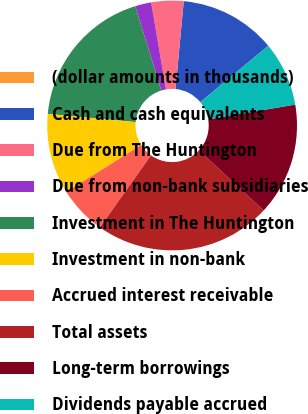Convert chart to OTSL. <chart><loc_0><loc_0><loc_500><loc_500><pie_chart><fcel>(dollar amounts in thousands)<fcel>Cash and cash equivalents<fcel>Due from The Huntington<fcel>Due from non-bank subsidiaries<fcel>Investment in The Huntington<fcel>Investment in non-bank<fcel>Accrued interest receivable<fcel>Total assets<fcel>Long-term borrowings<fcel>Dividends payable accrued<nl><fcel>0.01%<fcel>12.5%<fcel>4.17%<fcel>2.09%<fcel>18.75%<fcel>10.42%<fcel>6.25%<fcel>22.91%<fcel>14.58%<fcel>8.33%<nl></chart> 